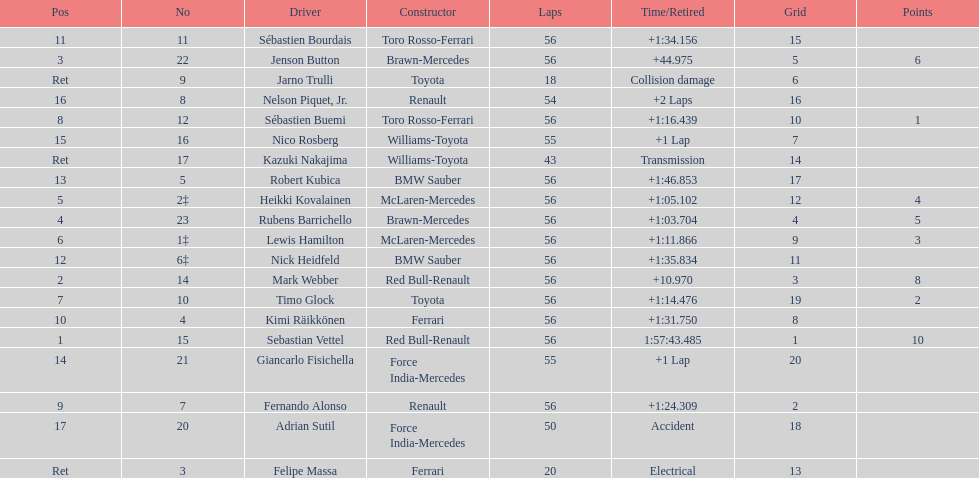Parse the table in full. {'header': ['Pos', 'No', 'Driver', 'Constructor', 'Laps', 'Time/Retired', 'Grid', 'Points'], 'rows': [['11', '11', 'Sébastien Bourdais', 'Toro Rosso-Ferrari', '56', '+1:34.156', '15', ''], ['3', '22', 'Jenson Button', 'Brawn-Mercedes', '56', '+44.975', '5', '6'], ['Ret', '9', 'Jarno Trulli', 'Toyota', '18', 'Collision damage', '6', ''], ['16', '8', 'Nelson Piquet, Jr.', 'Renault', '54', '+2 Laps', '16', ''], ['8', '12', 'Sébastien Buemi', 'Toro Rosso-Ferrari', '56', '+1:16.439', '10', '1'], ['15', '16', 'Nico Rosberg', 'Williams-Toyota', '55', '+1 Lap', '7', ''], ['Ret', '17', 'Kazuki Nakajima', 'Williams-Toyota', '43', 'Transmission', '14', ''], ['13', '5', 'Robert Kubica', 'BMW Sauber', '56', '+1:46.853', '17', ''], ['5', '2‡', 'Heikki Kovalainen', 'McLaren-Mercedes', '56', '+1:05.102', '12', '4'], ['4', '23', 'Rubens Barrichello', 'Brawn-Mercedes', '56', '+1:03.704', '4', '5'], ['6', '1‡', 'Lewis Hamilton', 'McLaren-Mercedes', '56', '+1:11.866', '9', '3'], ['12', '6‡', 'Nick Heidfeld', 'BMW Sauber', '56', '+1:35.834', '11', ''], ['2', '14', 'Mark Webber', 'Red Bull-Renault', '56', '+10.970', '3', '8'], ['7', '10', 'Timo Glock', 'Toyota', '56', '+1:14.476', '19', '2'], ['10', '4', 'Kimi Räikkönen', 'Ferrari', '56', '+1:31.750', '8', ''], ['1', '15', 'Sebastian Vettel', 'Red Bull-Renault', '56', '1:57:43.485', '1', '10'], ['14', '21', 'Giancarlo Fisichella', 'Force India-Mercedes', '55', '+1 Lap', '20', ''], ['9', '7', 'Fernando Alonso', 'Renault', '56', '+1:24.309', '2', ''], ['17', '20', 'Adrian Sutil', 'Force India-Mercedes', '50', 'Accident', '18', ''], ['Ret', '3', 'Felipe Massa', 'Ferrari', '20', 'Electrical', '13', '']]} Why did the  toyota retire Collision damage. What was the drivers name? Jarno Trulli. 